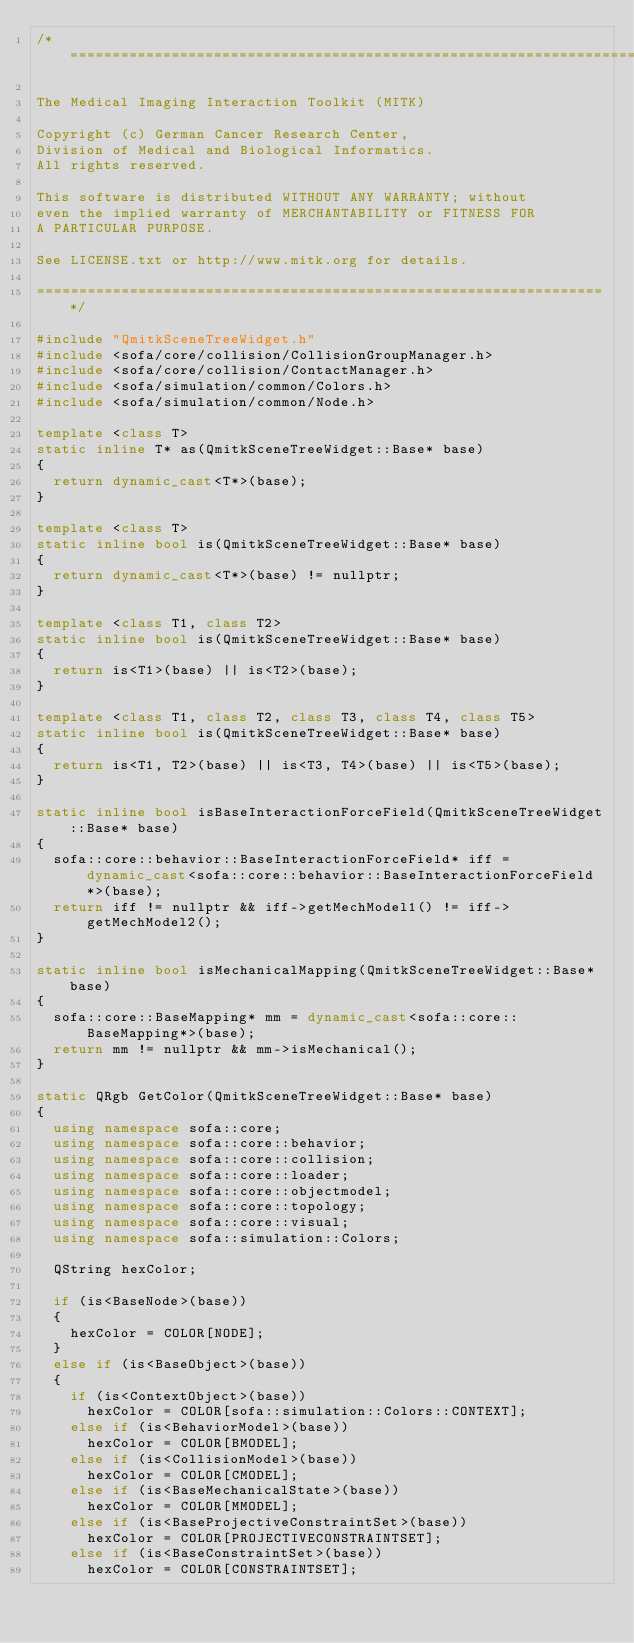<code> <loc_0><loc_0><loc_500><loc_500><_C++_>/*===================================================================

The Medical Imaging Interaction Toolkit (MITK)

Copyright (c) German Cancer Research Center,
Division of Medical and Biological Informatics.
All rights reserved.

This software is distributed WITHOUT ANY WARRANTY; without
even the implied warranty of MERCHANTABILITY or FITNESS FOR
A PARTICULAR PURPOSE.

See LICENSE.txt or http://www.mitk.org for details.

===================================================================*/

#include "QmitkSceneTreeWidget.h"
#include <sofa/core/collision/CollisionGroupManager.h>
#include <sofa/core/collision/ContactManager.h>
#include <sofa/simulation/common/Colors.h>
#include <sofa/simulation/common/Node.h>

template <class T>
static inline T* as(QmitkSceneTreeWidget::Base* base)
{
  return dynamic_cast<T*>(base);
}

template <class T>
static inline bool is(QmitkSceneTreeWidget::Base* base)
{
  return dynamic_cast<T*>(base) != nullptr;
}

template <class T1, class T2>
static inline bool is(QmitkSceneTreeWidget::Base* base)
{
  return is<T1>(base) || is<T2>(base);
}

template <class T1, class T2, class T3, class T4, class T5>
static inline bool is(QmitkSceneTreeWidget::Base* base)
{
  return is<T1, T2>(base) || is<T3, T4>(base) || is<T5>(base);
}

static inline bool isBaseInteractionForceField(QmitkSceneTreeWidget::Base* base)
{
  sofa::core::behavior::BaseInteractionForceField* iff = dynamic_cast<sofa::core::behavior::BaseInteractionForceField*>(base);
  return iff != nullptr && iff->getMechModel1() != iff->getMechModel2();
}

static inline bool isMechanicalMapping(QmitkSceneTreeWidget::Base* base)
{
  sofa::core::BaseMapping* mm = dynamic_cast<sofa::core::BaseMapping*>(base);
  return mm != nullptr && mm->isMechanical();
}

static QRgb GetColor(QmitkSceneTreeWidget::Base* base)
{
  using namespace sofa::core;
  using namespace sofa::core::behavior;
  using namespace sofa::core::collision;
  using namespace sofa::core::loader;
  using namespace sofa::core::objectmodel;
  using namespace sofa::core::topology;
  using namespace sofa::core::visual;
  using namespace sofa::simulation::Colors;

  QString hexColor;

  if (is<BaseNode>(base))
  {
    hexColor = COLOR[NODE];
  }
  else if (is<BaseObject>(base))
  {
    if (is<ContextObject>(base))
      hexColor = COLOR[sofa::simulation::Colors::CONTEXT];
    else if (is<BehaviorModel>(base))
      hexColor = COLOR[BMODEL];
    else if (is<CollisionModel>(base))
      hexColor = COLOR[CMODEL];
    else if (is<BaseMechanicalState>(base))
      hexColor = COLOR[MMODEL];
    else if (is<BaseProjectiveConstraintSet>(base))
      hexColor = COLOR[PROJECTIVECONSTRAINTSET];
    else if (is<BaseConstraintSet>(base))
      hexColor = COLOR[CONSTRAINTSET];</code> 